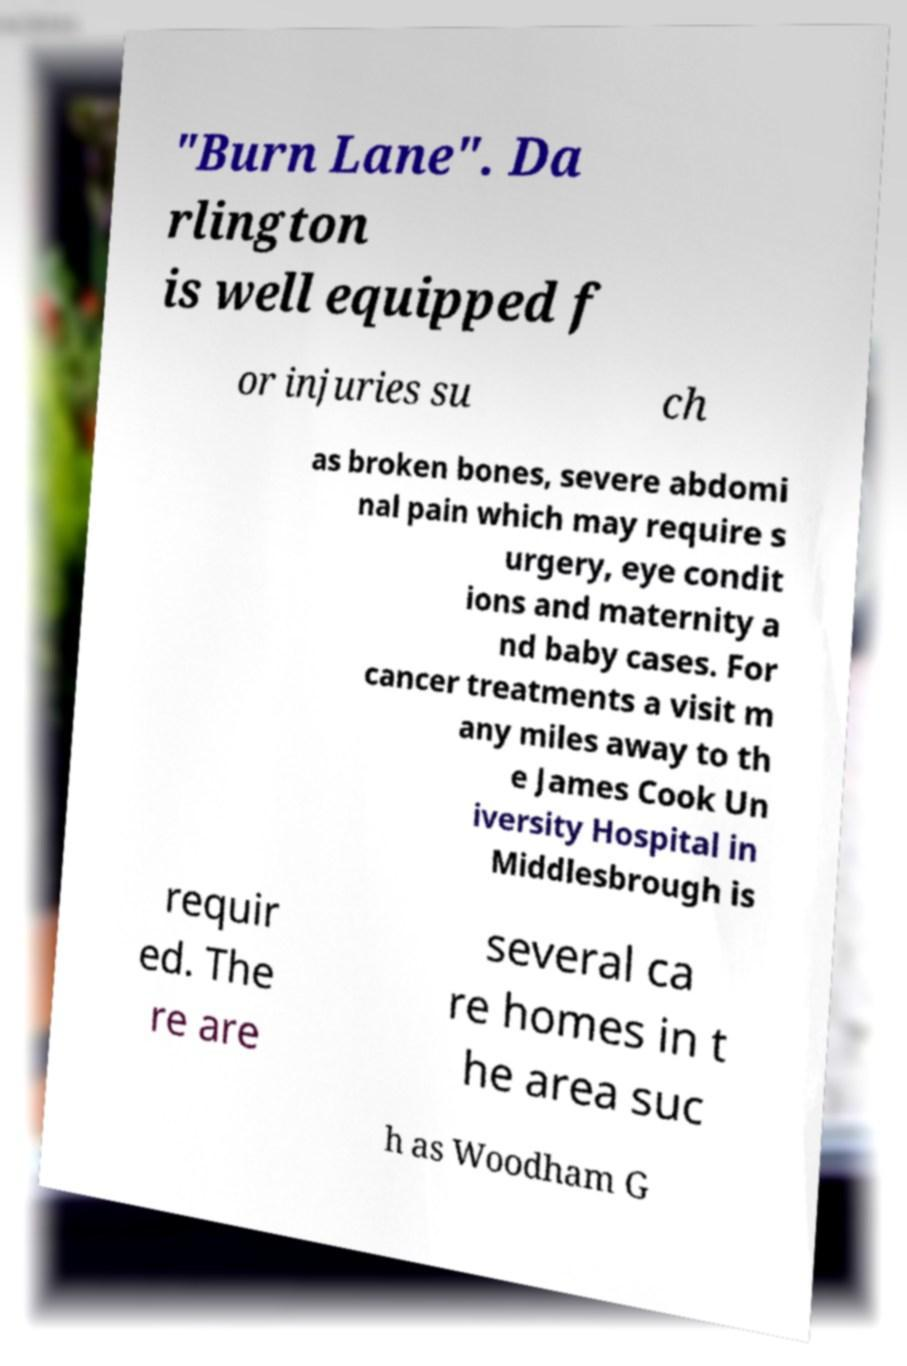I need the written content from this picture converted into text. Can you do that? "Burn Lane". Da rlington is well equipped f or injuries su ch as broken bones, severe abdomi nal pain which may require s urgery, eye condit ions and maternity a nd baby cases. For cancer treatments a visit m any miles away to th e James Cook Un iversity Hospital in Middlesbrough is requir ed. The re are several ca re homes in t he area suc h as Woodham G 